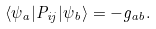<formula> <loc_0><loc_0><loc_500><loc_500>\langle \psi _ { a } | P _ { i j } | \psi _ { b } \rangle = - g _ { a b } .</formula> 